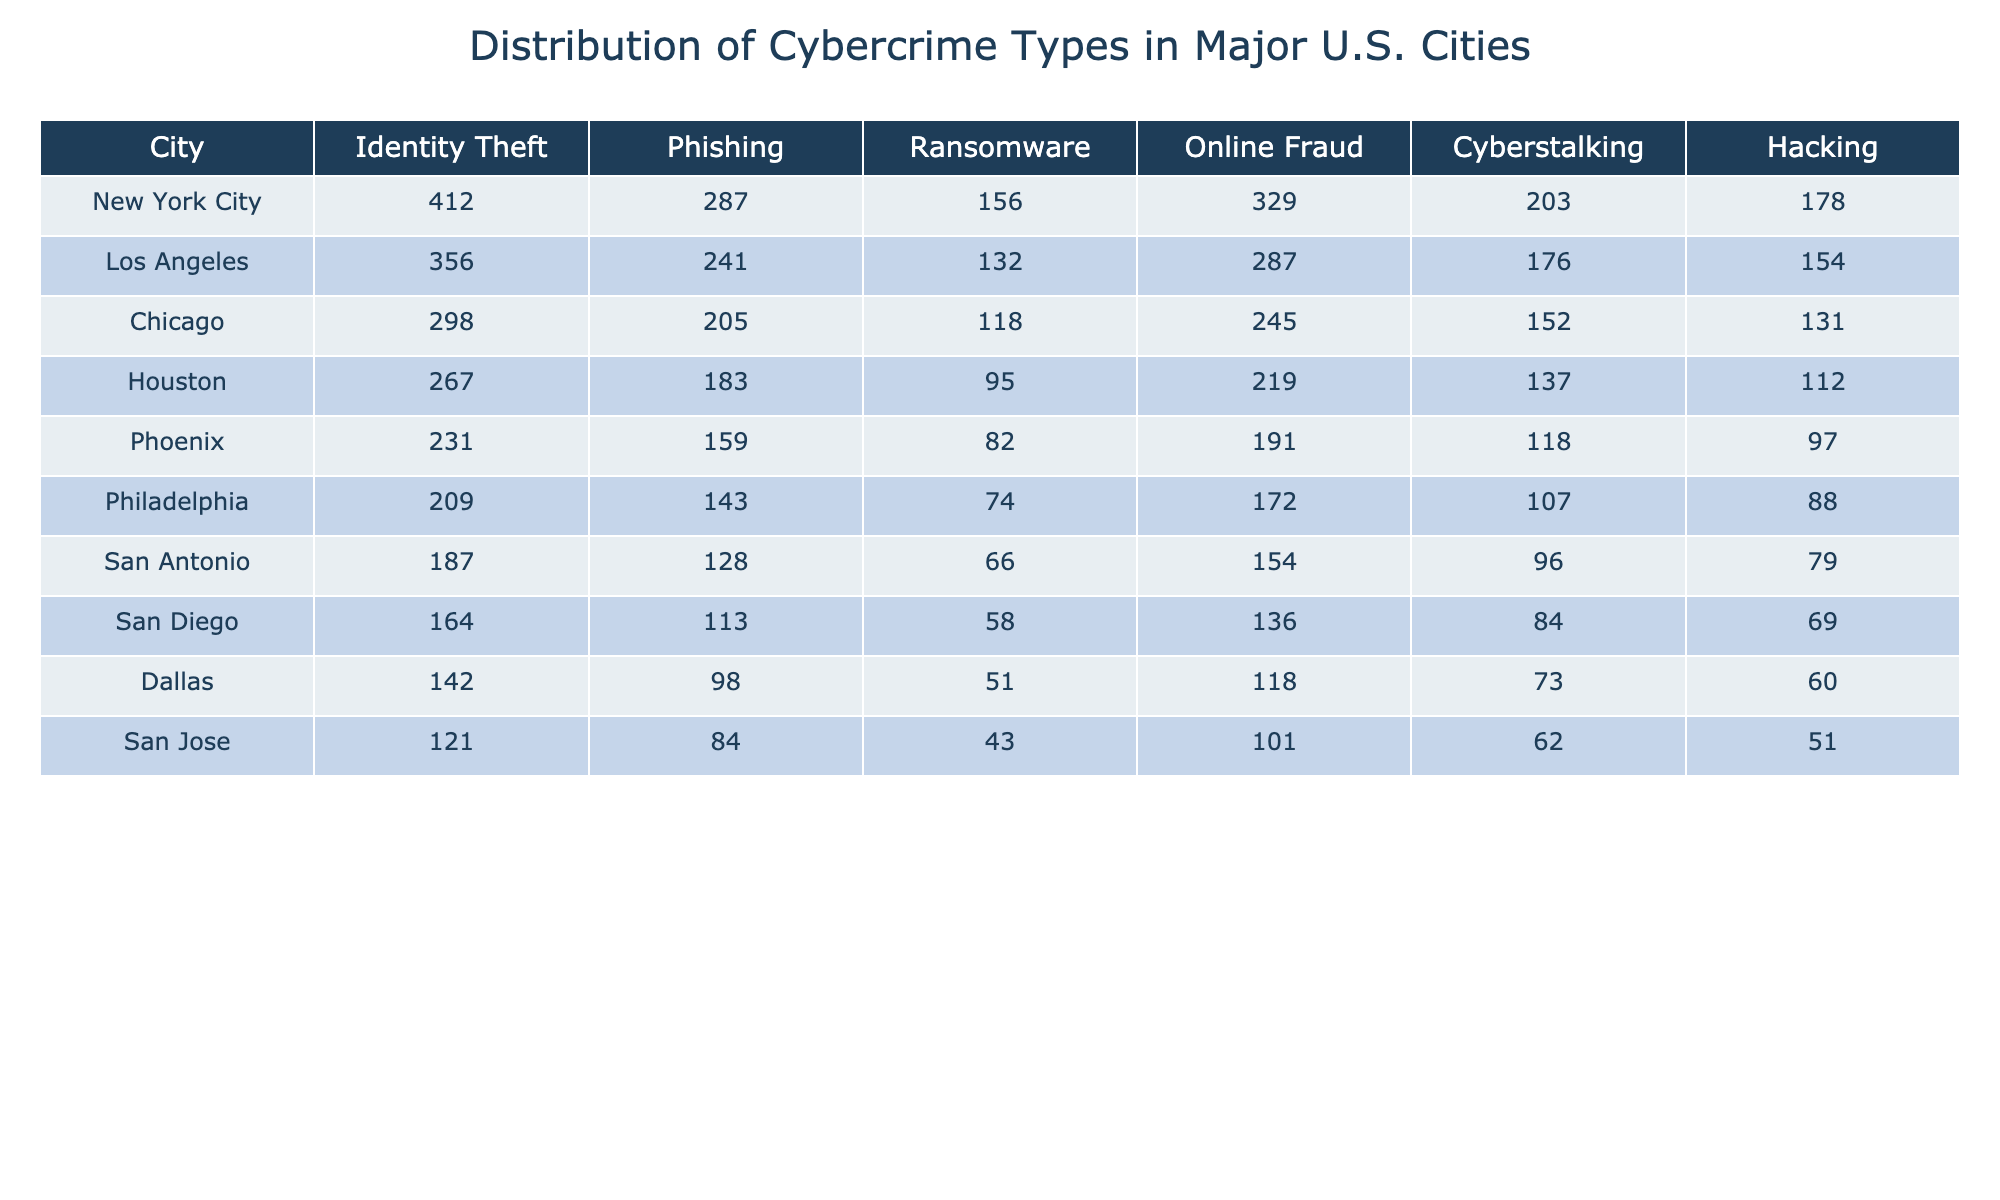What's the highest number of identity theft cases reported? Looking at the "Identity Theft" column, New York City has the highest value with 412 cases.
Answer: 412 Which city reported the least number of ransomware incidents? In the "Ransomware" column, San Jose has the lowest value with 43 cases.
Answer: 43 How many phishing cases were reported in Chicago? The value in the "Phishing" column for Chicago is 205 cases.
Answer: 205 Which city reported the highest total number of online fraud cases? By summing the counts in the "Online Fraud" column, New York City has the highest total with 329 cases.
Answer: 329 Is it true that Philadelphia reported more cyberstalking cases than Houston? In the "Cyberstalking" column, Philadelphia reported 107 cases and Houston reported 137 cases, so this statement is false.
Answer: No What is the average number of hacking incidents across all the cities listed? Adding up the hacking cases: 178 + 154 + 131 + 112 + 97 + 88 + 79 + 69 + 60 + 51 = 979. There are 10 cities, so the average is 979 / 10 = 97.9.
Answer: 97.9 Which two cities reported the highest and lowest number of phishing cases? New York City has the highest with 287 cases and San Jose has the lowest with 84 cases.
Answer: New York City and San Jose If we combine the numbers for identity theft and online fraud for Los Angeles, what is the total? For Los Angeles, identity theft is 356 and online fraud is 287. Adding these two gives a total of 356 + 287 = 643 cases.
Answer: 643 What is the difference in the number of cyberstalking cases between New York City and San Diego? New York City has 203 cases and San Diego has 84 cases. The difference is 203 - 84 = 119 cases.
Answer: 119 Which city has a higher incidence of online fraud: Chicago or Phoenix? Chicago has 245 cases of online fraud compared to Phoenix which has 191. Therefore, Chicago has a higher incidence.
Answer: Chicago 